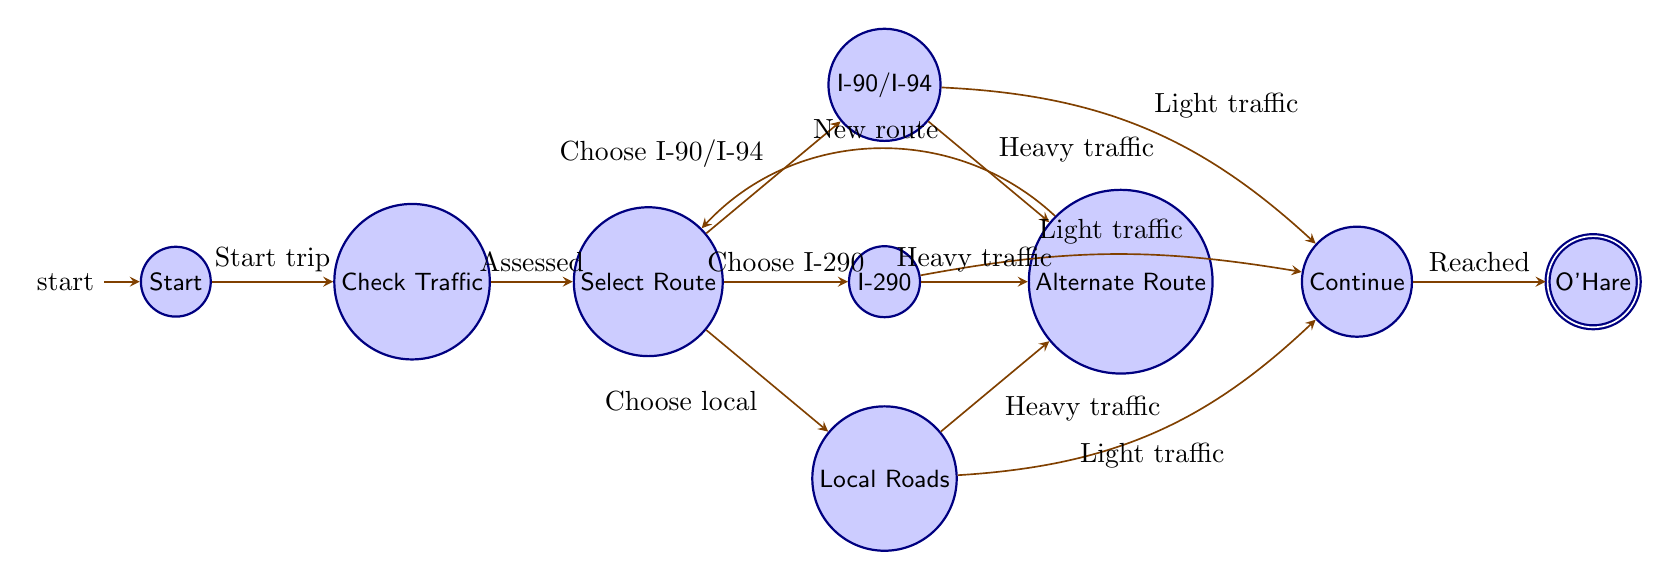What is the starting point of the journey? The diagram indicates that the starting point of the journey is labeled "Downtown Chicago," which is the first state in the finite state machine.
Answer: Downtown Chicago How many nodes are there in total? By counting each unique state listed in the diagram, including the starting and ending points, there are eight nodes.
Answer: Eight What action is taken in "Check Traffic"? The entry action for the "Check Traffic" state specifies "Consult GPS or traffic app," indicating this is the activity performed when this state is entered.
Answer: Consult GPS or traffic app What happens if traffic is heavy on I-90/I-94? If the traffic condition while driving on I-90/I-94 is heavy, the transition occurs to the "Switch to Alternate Route" state, indicating a need to find a new route.
Answer: Switch to Alternate Route Which states lead to the "Continue to O'Hare" node from "Select Route"? The states that can transition to "Continue to O'Hare" from "Select Route" based on light traffic are "Drive on I-90/I-94," "Drive on I-290," and "Drive on Local Roads," meaning any of these routes under light traffic conditions will lead to continuing towards O'Hare.
Answer: Drive on I-90/I-94, Drive on I-290, Drive on Local Roads What must happen before selecting a route? The transition shows that before selecting a route, the condition "Traffic conditions assessed" must be satisfied, meaning that traffic assessment needs to be completed first.
Answer: Traffic conditions assessed From which state will the journey end? The journey concludes at the "Arrive at O'Hare" node, which is the last state in the finite state machine representing reaching the airport.
Answer: Arrive at O'Hare What is the condition for transitioning from "Continue to O'Hare" to "Arrive at O'Hare"? The condition for moving from "Continue to O'Hare" to "Arrive at O'Hare" is when the action "Reached O'Hare" takes place, confirming arrival at the airport.
Answer: Reached O'Hare What action follows after finding an alternate route? The subsequent action after finding an alternate route is to consult the GPS again and return to the "Select Route" state to choose a new pathway.
Answer: Select Route 